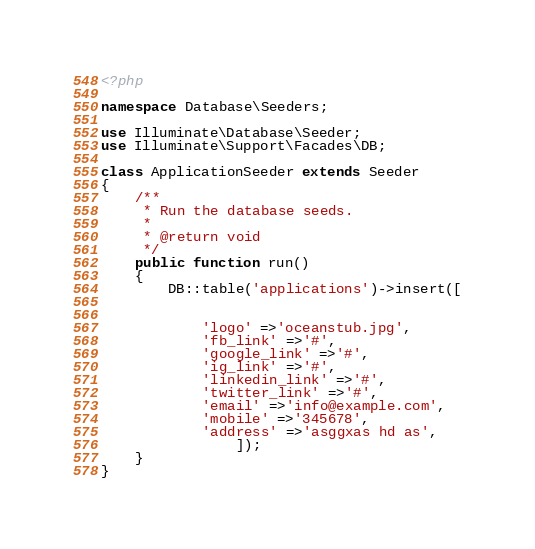<code> <loc_0><loc_0><loc_500><loc_500><_PHP_><?php

namespace Database\Seeders;

use Illuminate\Database\Seeder;
use Illuminate\Support\Facades\DB;

class ApplicationSeeder extends Seeder
{
    /**
     * Run the database seeds.
     *
     * @return void
     */
    public function run()
    {
        DB::table('applications')->insert([


            'logo' =>'oceanstub.jpg',
            'fb_link' =>'#',
            'google_link' =>'#',
            'ig_link' =>'#',
            'linkedin_link' =>'#',
            'twitter_link' =>'#',
            'email' =>'info@example.com',
            'mobile' =>'345678',
            'address' =>'asggxas hd as',
                ]);
    }
}
</code> 